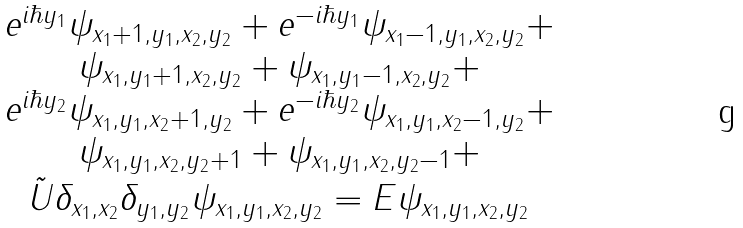<formula> <loc_0><loc_0><loc_500><loc_500>\begin{array} { c } e ^ { i \hbar { y } _ { 1 } } \psi _ { x _ { 1 } + 1 , y _ { 1 } , x _ { 2 } , y _ { 2 } } + e ^ { - i \hbar { y } _ { 1 } } \psi _ { x _ { 1 } - 1 , y _ { 1 } , x _ { 2 } , y _ { 2 } } + \\ \psi _ { x _ { 1 } , y _ { 1 } + 1 , x _ { 2 } , y _ { 2 } } + \psi _ { x _ { 1 } , y _ { 1 } - 1 , x _ { 2 } , y _ { 2 } } + \\ e ^ { i \hbar { y } _ { 2 } } \psi _ { x _ { 1 } , y _ { 1 } , x _ { 2 } + 1 , y _ { 2 } } + e ^ { - i \hbar { y } _ { 2 } } \psi _ { x _ { 1 } , y _ { 1 } , x _ { 2 } - 1 , y _ { 2 } } + \\ \psi _ { x _ { 1 } , y _ { 1 } , x _ { 2 } , y _ { 2 } + 1 } + \psi _ { x _ { 1 } , y _ { 1 } , x _ { 2 } , y _ { 2 } - 1 } + \\ \tilde { U } \delta _ { x _ { 1 } , x _ { 2 } } \delta _ { y _ { 1 } , y _ { 2 } } \psi _ { x _ { 1 } , y _ { 1 } , x _ { 2 } , y _ { 2 } } = E \psi _ { x _ { 1 } , y _ { 1 } , x _ { 2 } , y _ { 2 } } \end{array}</formula> 